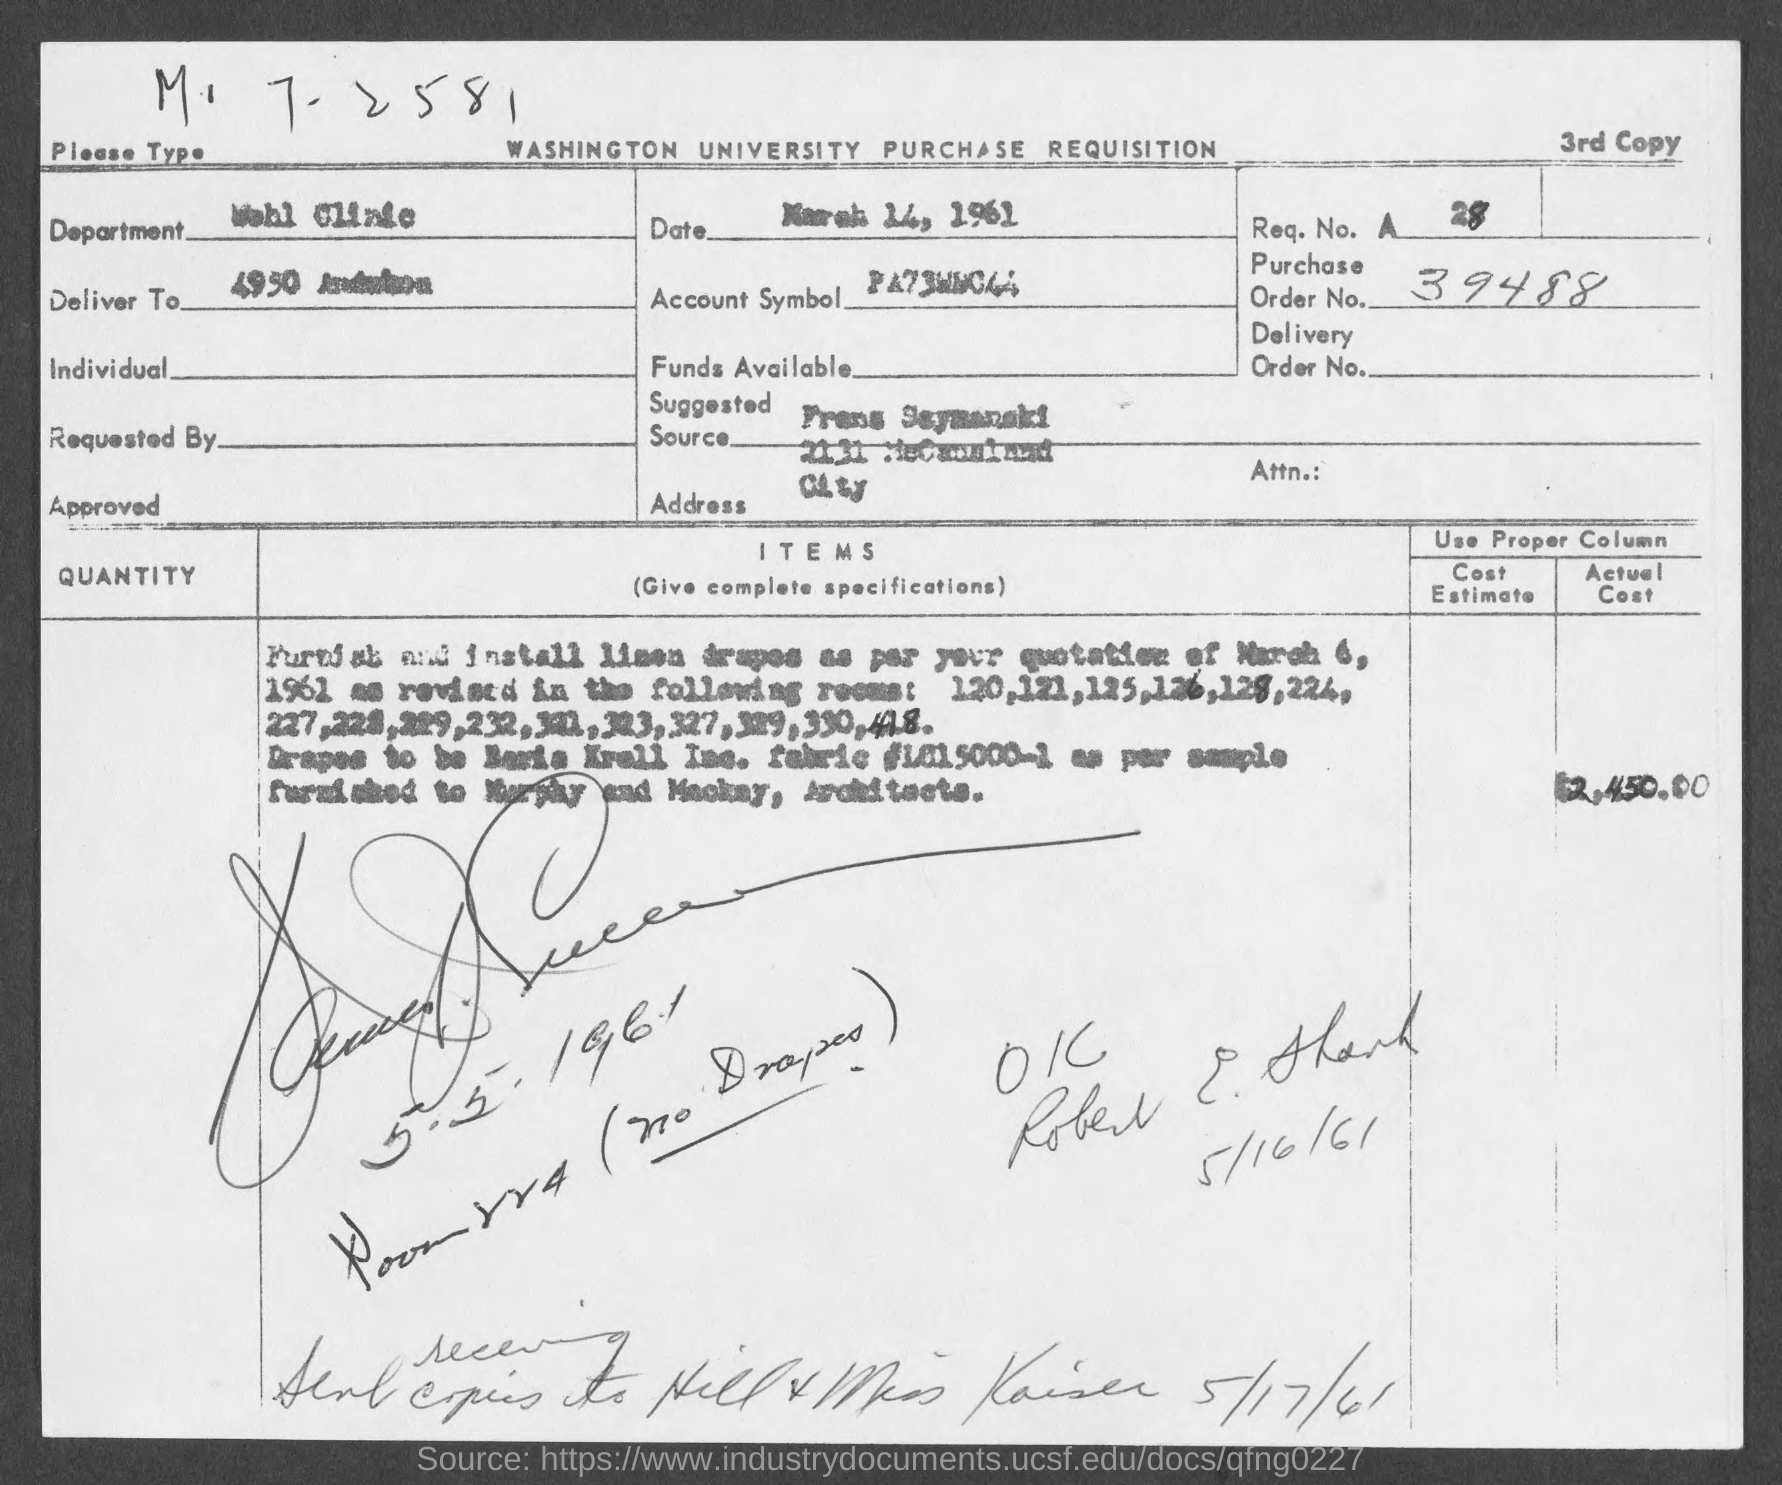Mention a couple of crucial points in this snapshot. The order number mentioned on the given page is 39488. The date mentioned in the given page is March 14, 1961. The department mentioned in the given form is the Wohl Clinic. The request number mentioned in the given page is 28. 